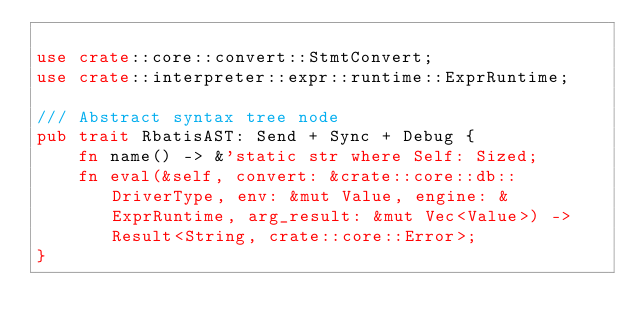Convert code to text. <code><loc_0><loc_0><loc_500><loc_500><_Rust_>
use crate::core::convert::StmtConvert;
use crate::interpreter::expr::runtime::ExprRuntime;

/// Abstract syntax tree node
pub trait RbatisAST: Send + Sync + Debug {
    fn name() -> &'static str where Self: Sized;
    fn eval(&self, convert: &crate::core::db::DriverType, env: &mut Value, engine: &ExprRuntime, arg_result: &mut Vec<Value>) -> Result<String, crate::core::Error>;
}</code> 